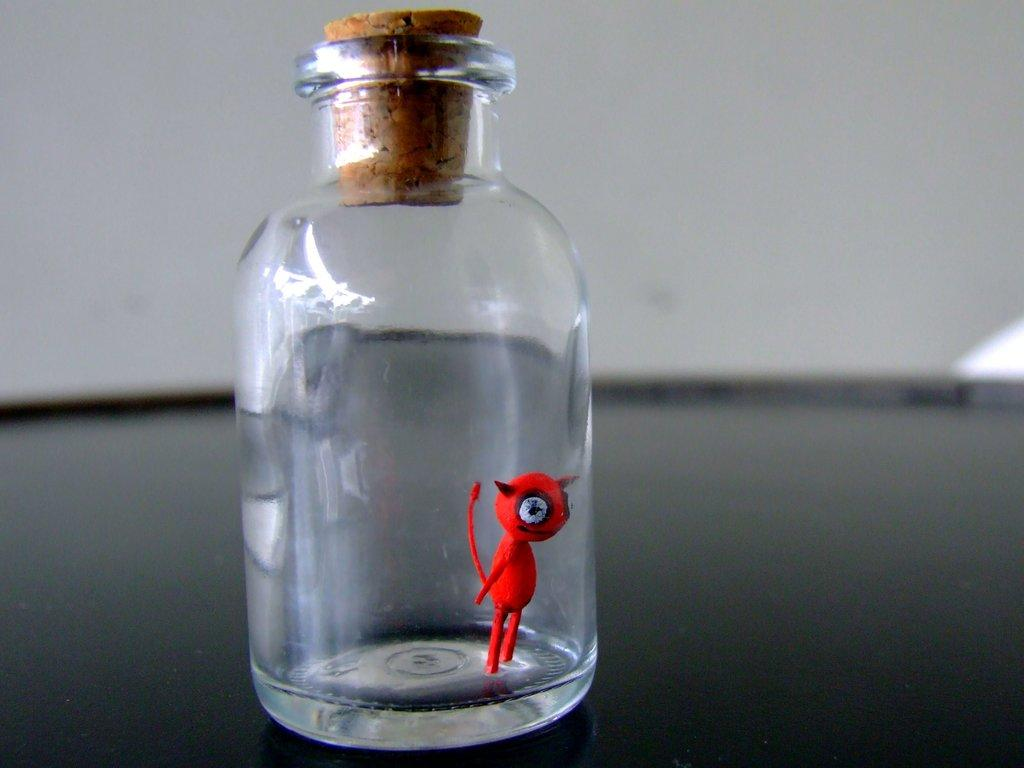What object is visible in the image that is made of glass? There is a glass jar in the image. What is inside the glass jar? There is a toy inside the glass jar. What type of insect can be seen crawling on the plough in the image? There is no plough or insect present in the image. 